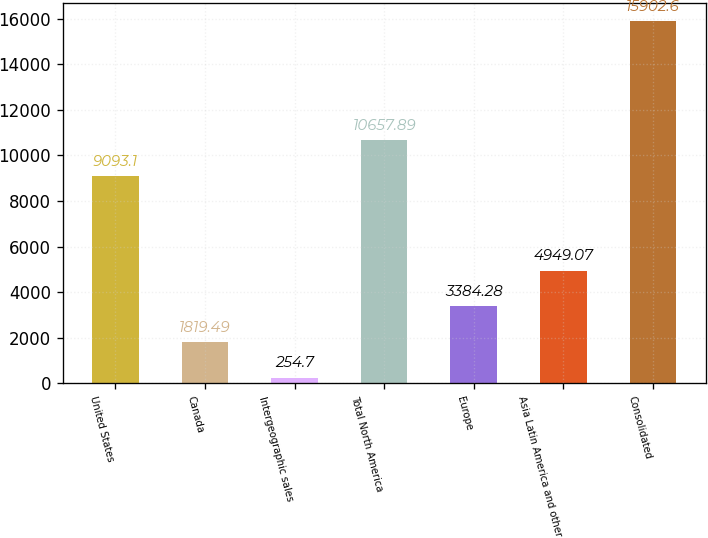<chart> <loc_0><loc_0><loc_500><loc_500><bar_chart><fcel>United States<fcel>Canada<fcel>Intergeographic sales<fcel>Total North America<fcel>Europe<fcel>Asia Latin America and other<fcel>Consolidated<nl><fcel>9093.1<fcel>1819.49<fcel>254.7<fcel>10657.9<fcel>3384.28<fcel>4949.07<fcel>15902.6<nl></chart> 